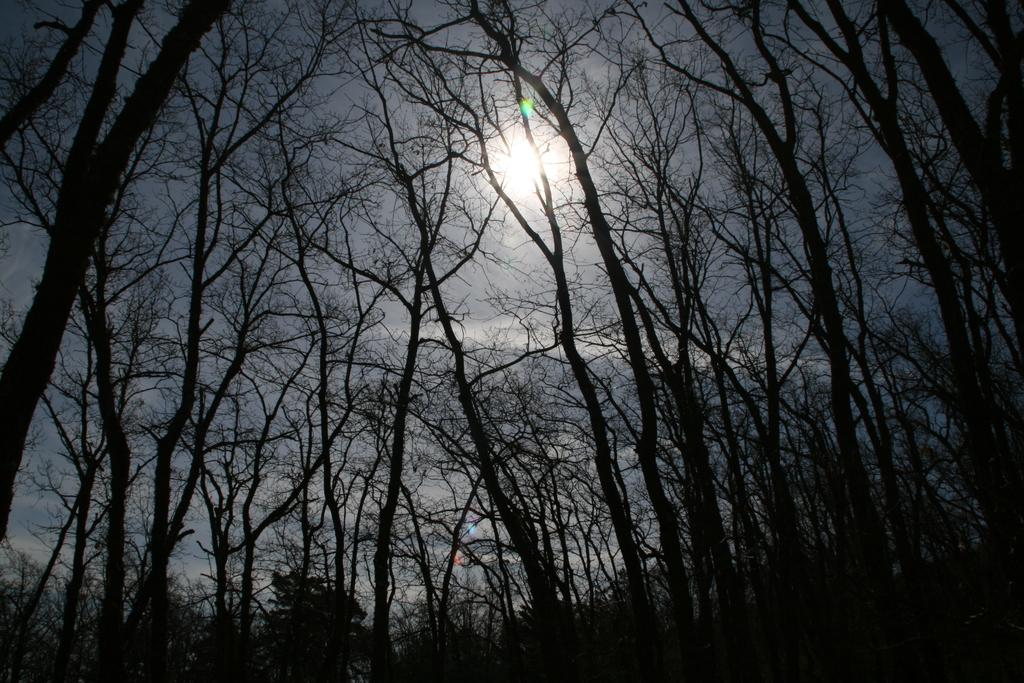What type of natural environment is depicted in the image? The image contains many trees, indicating a forest or wooded area. What can be seen in the sky in the image? The sky is visible in the image, and the sun is observable. Can you describe the weather or time of day based on the image? The presence of the sun suggests it is daytime, but the specific weather cannot be determined from the image. What is the value of the brother's death in the image? There is no reference to a brother or death in the image, so it is not possible to determine the value of any such event. 